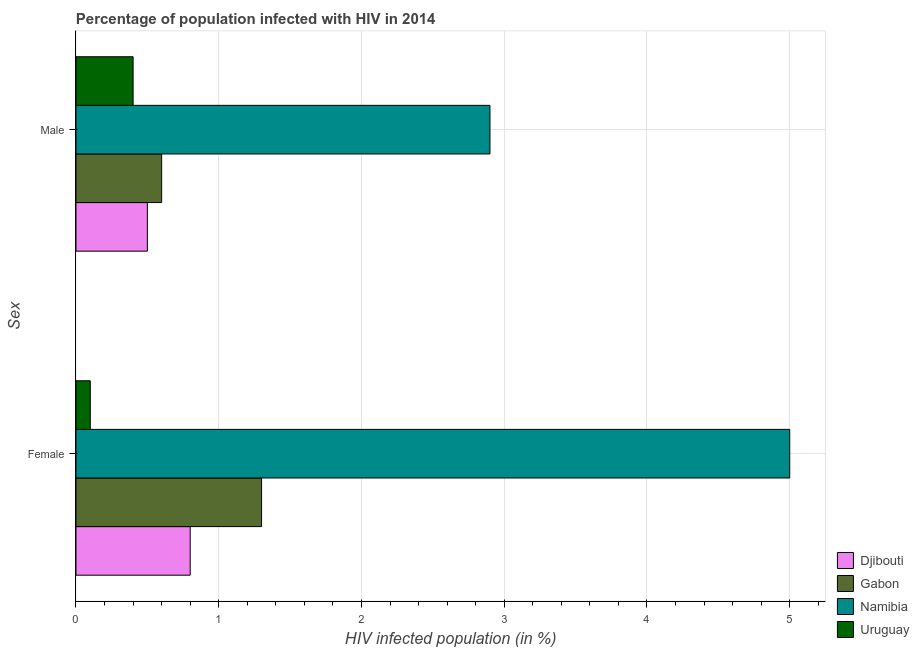How many different coloured bars are there?
Offer a terse response. 4. How many groups of bars are there?
Provide a short and direct response. 2. Are the number of bars per tick equal to the number of legend labels?
Your answer should be compact. Yes. Are the number of bars on each tick of the Y-axis equal?
Provide a short and direct response. Yes. How many bars are there on the 1st tick from the top?
Your answer should be very brief. 4. How many bars are there on the 2nd tick from the bottom?
Keep it short and to the point. 4. What is the percentage of females who are infected with hiv in Djibouti?
Offer a very short reply. 0.8. In which country was the percentage of females who are infected with hiv maximum?
Ensure brevity in your answer.  Namibia. In which country was the percentage of females who are infected with hiv minimum?
Offer a terse response. Uruguay. What is the total percentage of females who are infected with hiv in the graph?
Ensure brevity in your answer.  7.2. What is the difference between the percentage of females who are infected with hiv in Gabon and the percentage of males who are infected with hiv in Uruguay?
Ensure brevity in your answer.  0.9. What is the average percentage of females who are infected with hiv per country?
Offer a terse response. 1.8. What is the difference between the percentage of males who are infected with hiv and percentage of females who are infected with hiv in Namibia?
Offer a very short reply. -2.1. Is the percentage of males who are infected with hiv in Gabon less than that in Djibouti?
Ensure brevity in your answer.  No. What does the 1st bar from the top in Female represents?
Your answer should be compact. Uruguay. What does the 2nd bar from the bottom in Female represents?
Your answer should be very brief. Gabon. How many bars are there?
Your response must be concise. 8. How many countries are there in the graph?
Keep it short and to the point. 4. Does the graph contain any zero values?
Your answer should be compact. No. Where does the legend appear in the graph?
Give a very brief answer. Bottom right. How are the legend labels stacked?
Provide a succinct answer. Vertical. What is the title of the graph?
Ensure brevity in your answer.  Percentage of population infected with HIV in 2014. What is the label or title of the X-axis?
Offer a terse response. HIV infected population (in %). What is the label or title of the Y-axis?
Make the answer very short. Sex. What is the HIV infected population (in %) in Djibouti in Male?
Provide a succinct answer. 0.5. Across all Sex, what is the maximum HIV infected population (in %) of Djibouti?
Make the answer very short. 0.8. Across all Sex, what is the maximum HIV infected population (in %) of Gabon?
Offer a terse response. 1.3. Across all Sex, what is the maximum HIV infected population (in %) of Namibia?
Keep it short and to the point. 5. Across all Sex, what is the minimum HIV infected population (in %) in Gabon?
Your answer should be compact. 0.6. What is the total HIV infected population (in %) of Gabon in the graph?
Ensure brevity in your answer.  1.9. What is the difference between the HIV infected population (in %) of Gabon in Female and that in Male?
Keep it short and to the point. 0.7. What is the difference between the HIV infected population (in %) in Uruguay in Female and that in Male?
Make the answer very short. -0.3. What is the difference between the HIV infected population (in %) in Djibouti in Female and the HIV infected population (in %) in Gabon in Male?
Provide a succinct answer. 0.2. What is the difference between the HIV infected population (in %) of Djibouti in Female and the HIV infected population (in %) of Uruguay in Male?
Offer a very short reply. 0.4. What is the difference between the HIV infected population (in %) in Gabon in Female and the HIV infected population (in %) in Namibia in Male?
Provide a short and direct response. -1.6. What is the difference between the HIV infected population (in %) in Gabon in Female and the HIV infected population (in %) in Uruguay in Male?
Provide a short and direct response. 0.9. What is the difference between the HIV infected population (in %) of Namibia in Female and the HIV infected population (in %) of Uruguay in Male?
Provide a short and direct response. 4.6. What is the average HIV infected population (in %) in Djibouti per Sex?
Provide a succinct answer. 0.65. What is the average HIV infected population (in %) in Gabon per Sex?
Your answer should be compact. 0.95. What is the average HIV infected population (in %) in Namibia per Sex?
Make the answer very short. 3.95. What is the average HIV infected population (in %) of Uruguay per Sex?
Make the answer very short. 0.25. What is the difference between the HIV infected population (in %) of Djibouti and HIV infected population (in %) of Uruguay in Female?
Provide a succinct answer. 0.7. What is the difference between the HIV infected population (in %) of Gabon and HIV infected population (in %) of Namibia in Female?
Keep it short and to the point. -3.7. What is the difference between the HIV infected population (in %) of Gabon and HIV infected population (in %) of Uruguay in Female?
Your response must be concise. 1.2. What is the difference between the HIV infected population (in %) in Namibia and HIV infected population (in %) in Uruguay in Female?
Your answer should be very brief. 4.9. What is the difference between the HIV infected population (in %) in Djibouti and HIV infected population (in %) in Gabon in Male?
Give a very brief answer. -0.1. What is the difference between the HIV infected population (in %) in Gabon and HIV infected population (in %) in Namibia in Male?
Your response must be concise. -2.3. What is the difference between the HIV infected population (in %) of Namibia and HIV infected population (in %) of Uruguay in Male?
Ensure brevity in your answer.  2.5. What is the ratio of the HIV infected population (in %) in Gabon in Female to that in Male?
Give a very brief answer. 2.17. What is the ratio of the HIV infected population (in %) in Namibia in Female to that in Male?
Offer a very short reply. 1.72. What is the ratio of the HIV infected population (in %) in Uruguay in Female to that in Male?
Make the answer very short. 0.25. What is the difference between the highest and the second highest HIV infected population (in %) in Djibouti?
Provide a succinct answer. 0.3. What is the difference between the highest and the second highest HIV infected population (in %) of Namibia?
Offer a terse response. 2.1. What is the difference between the highest and the second highest HIV infected population (in %) of Uruguay?
Make the answer very short. 0.3. What is the difference between the highest and the lowest HIV infected population (in %) of Djibouti?
Your answer should be compact. 0.3. 